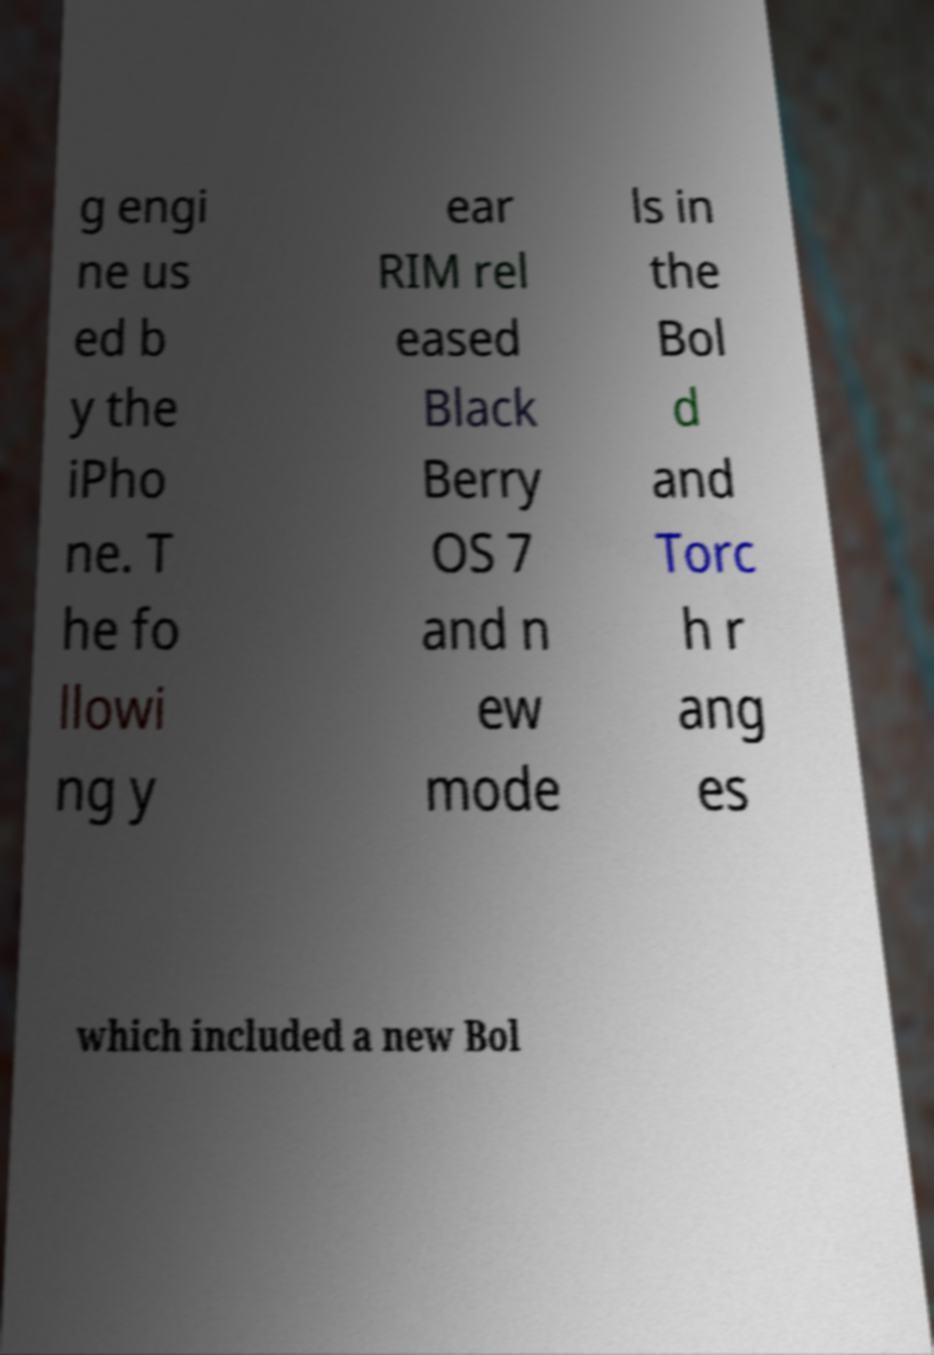Please identify and transcribe the text found in this image. g engi ne us ed b y the iPho ne. T he fo llowi ng y ear RIM rel eased Black Berry OS 7 and n ew mode ls in the Bol d and Torc h r ang es which included a new Bol 